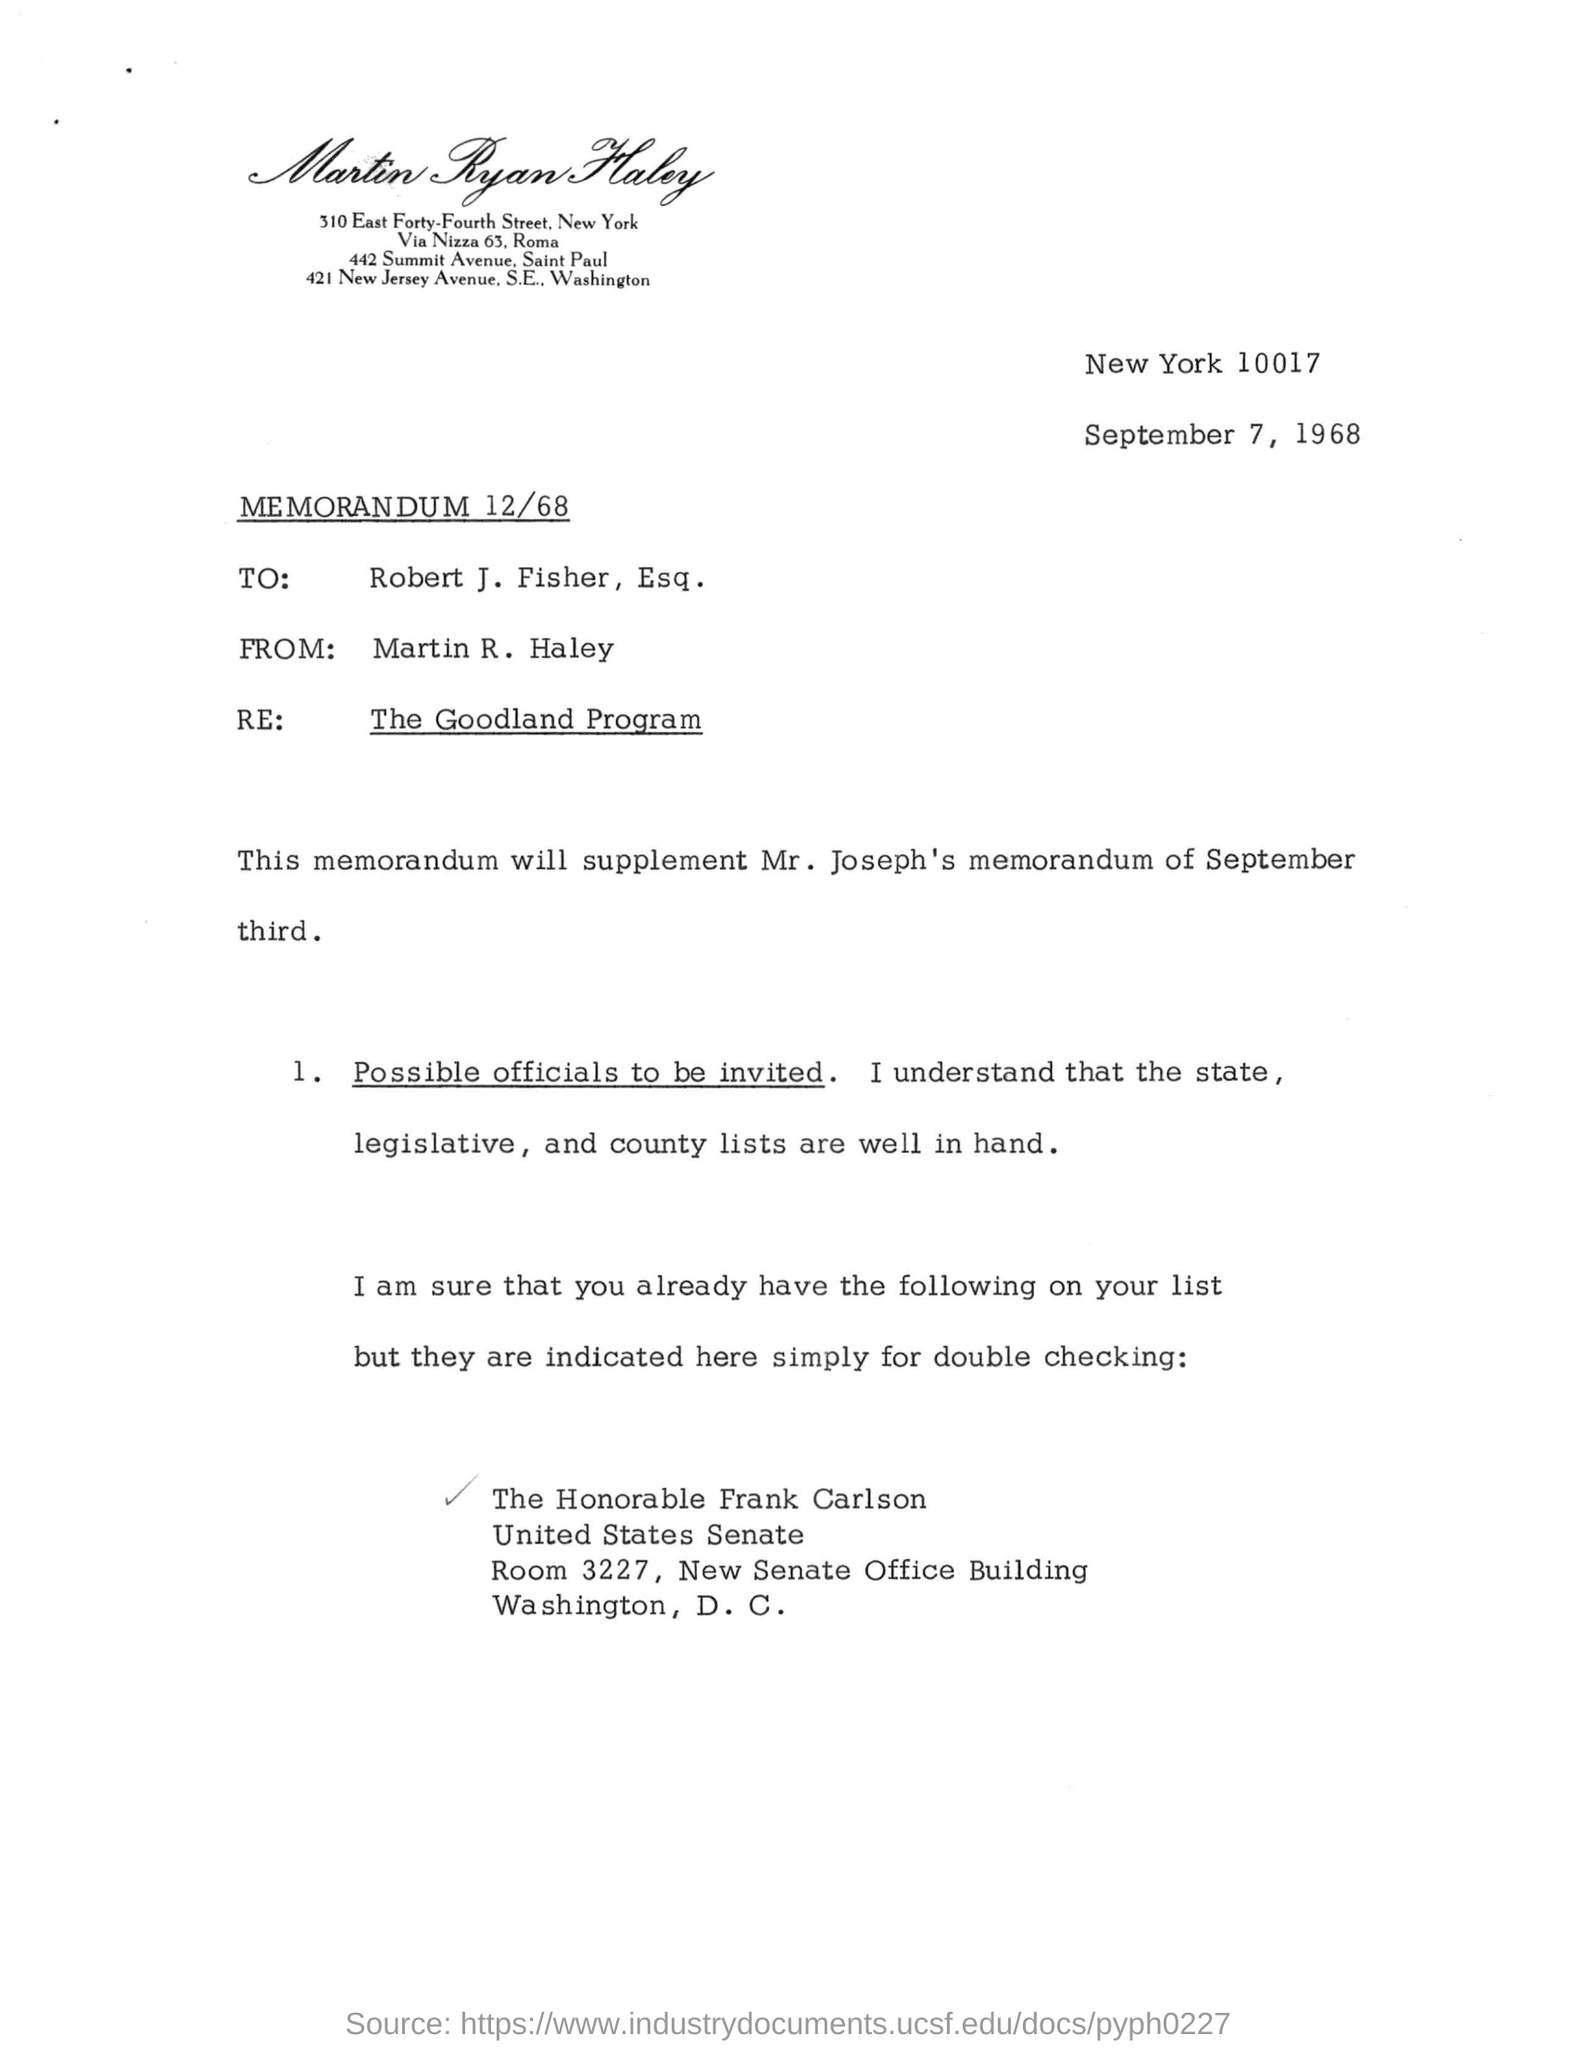Mention a couple of crucial points in this snapshot. The memorandum's title is "MEMORANDUM 12/68.. On the document, the date mentioned is September 7, 1968. Robert J. Fisher, Esq. is the recipient. 